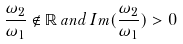<formula> <loc_0><loc_0><loc_500><loc_500>\frac { \omega _ { 2 } } { \omega _ { 1 } } \notin { \mathbb { R } } \, a n d \, I m ( \frac { \omega _ { 2 } } { \omega _ { 1 } } ) > 0</formula> 